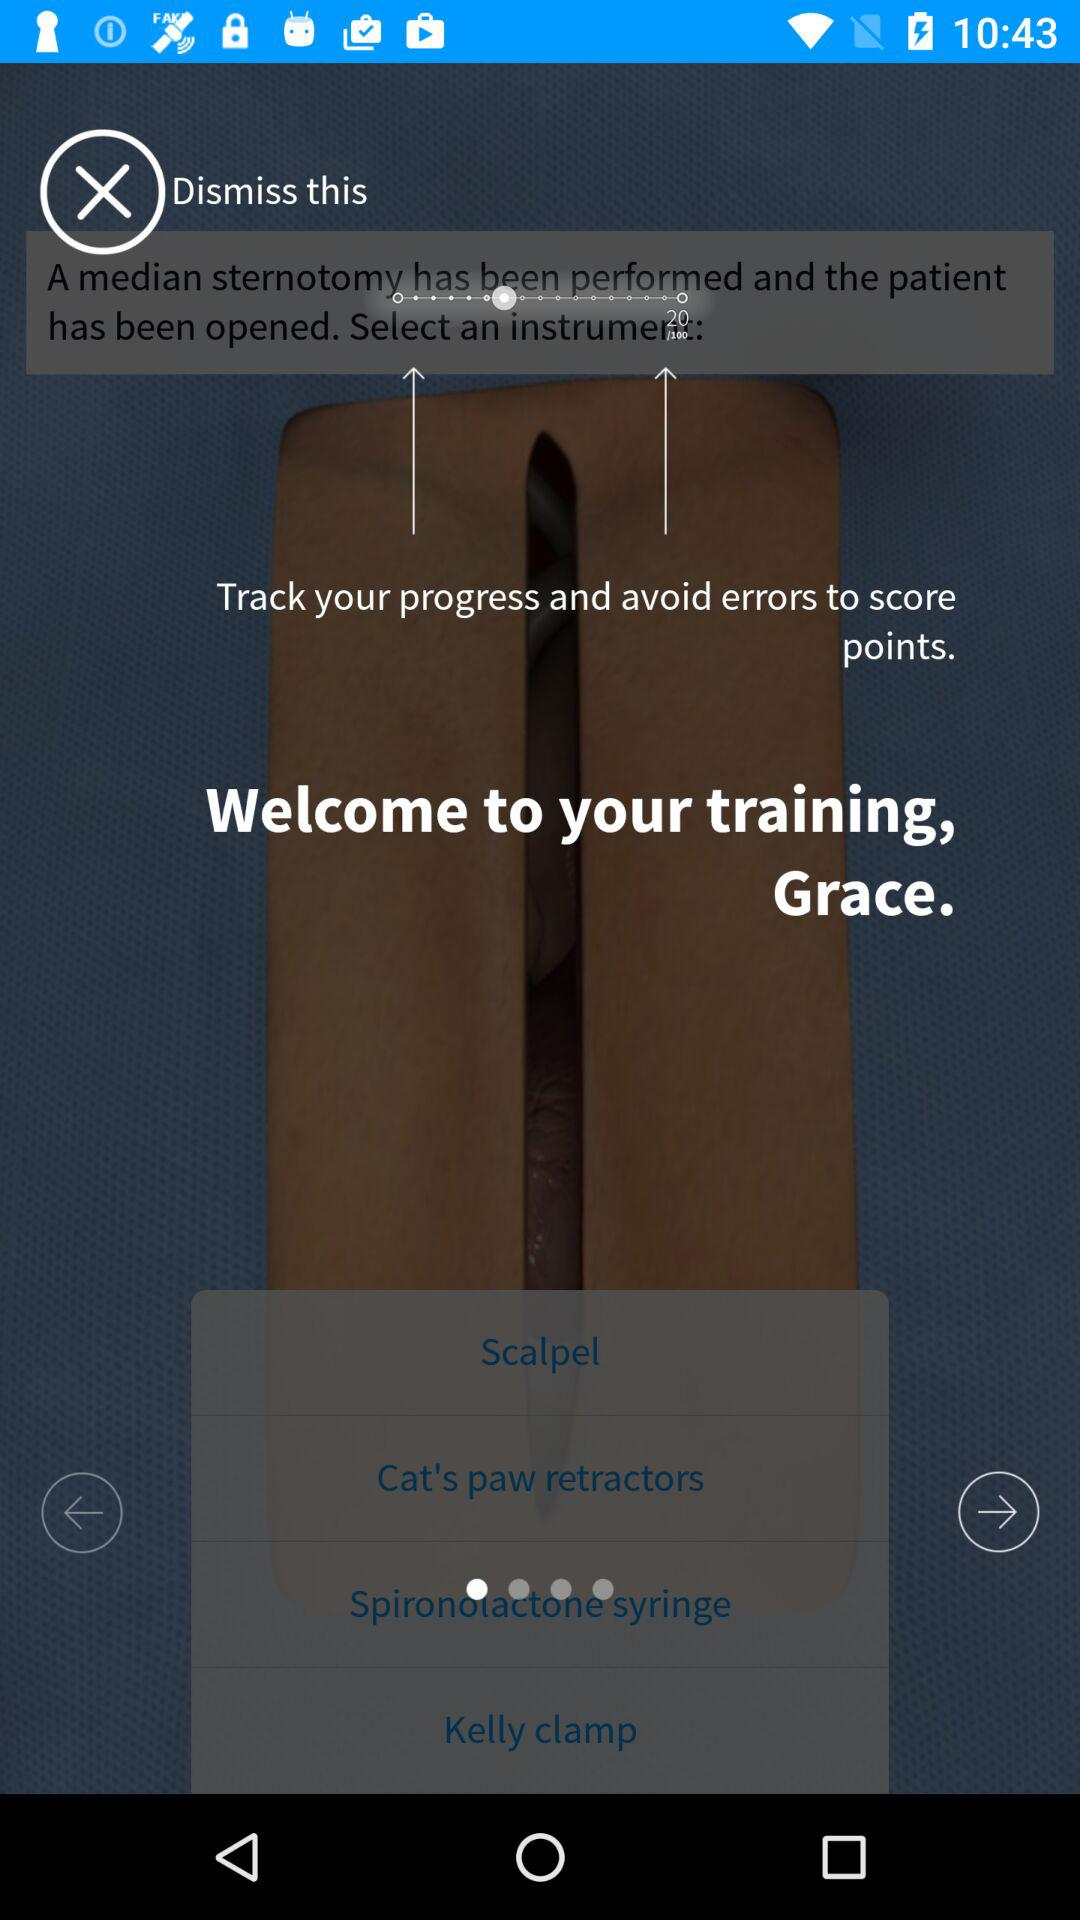Which instrument is selected?
When the provided information is insufficient, respond with <no answer>. <no answer> 